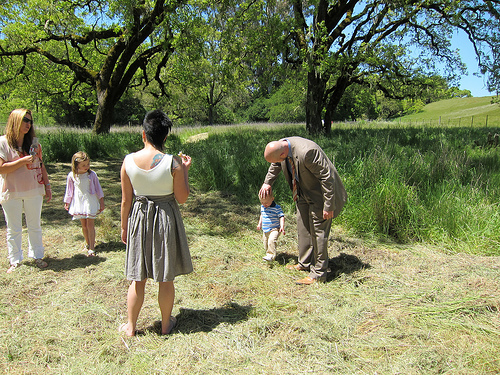<image>
Is the man behind the plant? No. The man is not behind the plant. From this viewpoint, the man appears to be positioned elsewhere in the scene. Where is the women in relation to the little girl? Is it next to the little girl? No. The women is not positioned next to the little girl. They are located in different areas of the scene. 